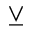<formula> <loc_0><loc_0><loc_500><loc_500>\veebar</formula> 